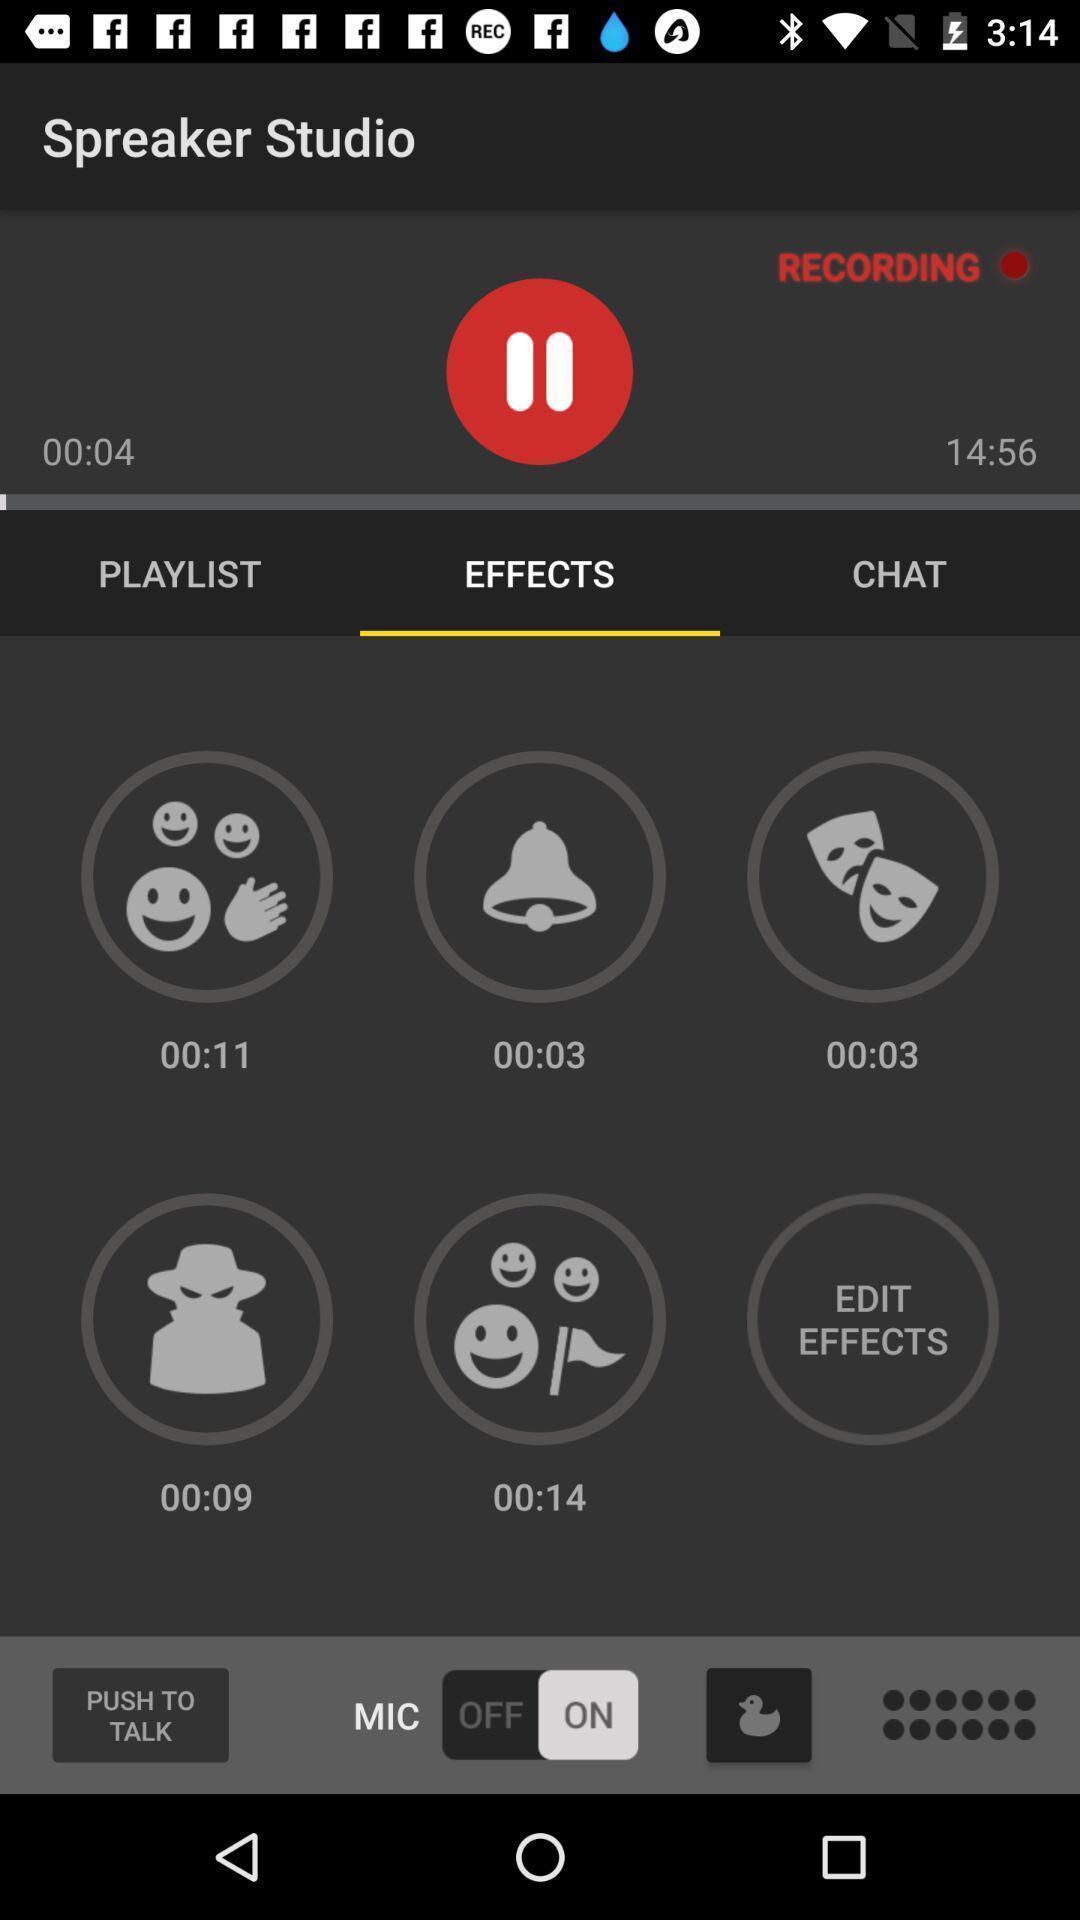Give me a narrative description of this picture. Various options in podcast creator app. 